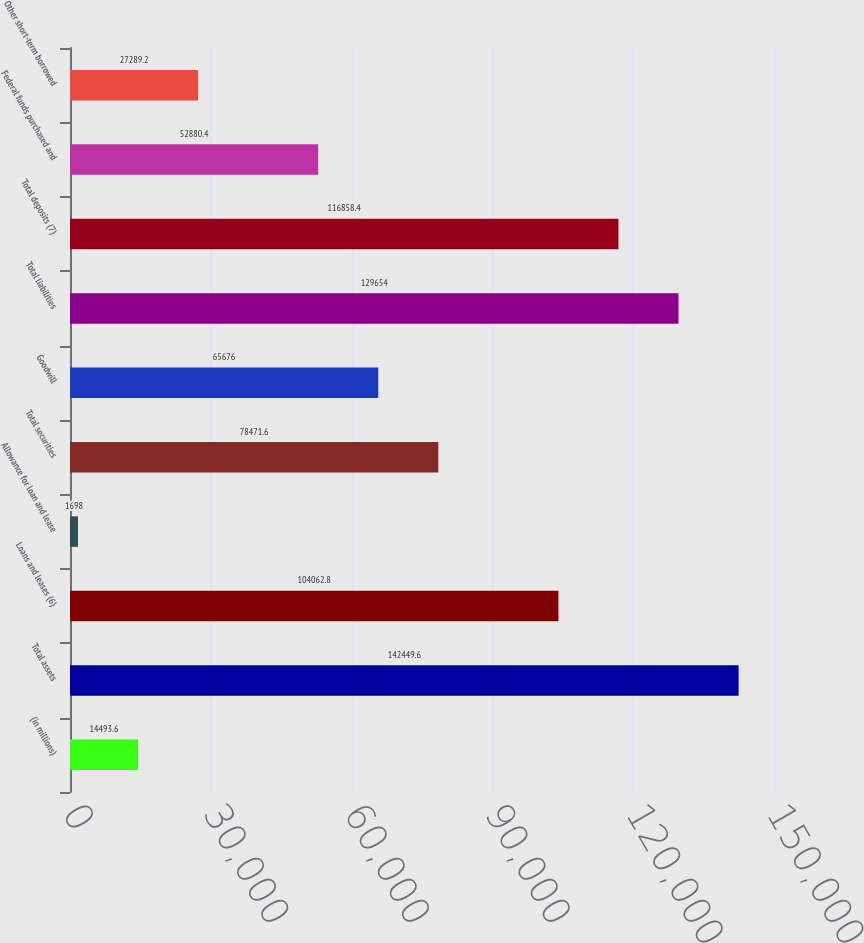Convert chart. <chart><loc_0><loc_0><loc_500><loc_500><bar_chart><fcel>(in millions)<fcel>Total assets<fcel>Loans and leases (6)<fcel>Allowance for loan and lease<fcel>Total securities<fcel>Goodwill<fcel>Total liabilities<fcel>Total deposits (7)<fcel>Federal funds purchased and<fcel>Other short-term borrowed<nl><fcel>14493.6<fcel>142450<fcel>104063<fcel>1698<fcel>78471.6<fcel>65676<fcel>129654<fcel>116858<fcel>52880.4<fcel>27289.2<nl></chart> 